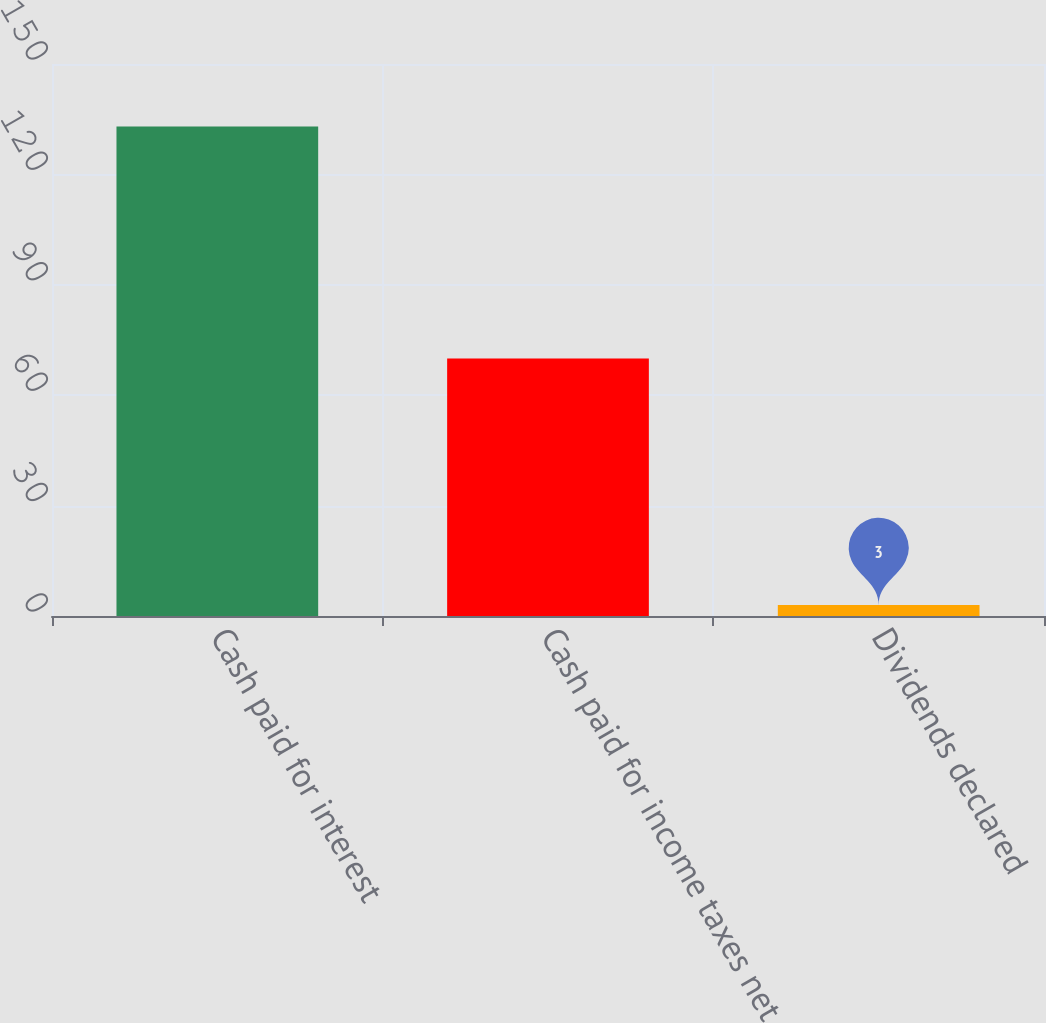Convert chart. <chart><loc_0><loc_0><loc_500><loc_500><bar_chart><fcel>Cash paid for interest<fcel>Cash paid for income taxes net<fcel>Dividends declared<nl><fcel>133<fcel>70<fcel>3<nl></chart> 